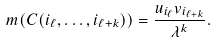<formula> <loc_0><loc_0><loc_500><loc_500>m ( C ( i _ { \ell } , \dots , i _ { \ell + k } ) ) = \frac { u _ { i _ { \ell } } v _ { i _ { \ell + k } } } { \lambda ^ { k } } .</formula> 